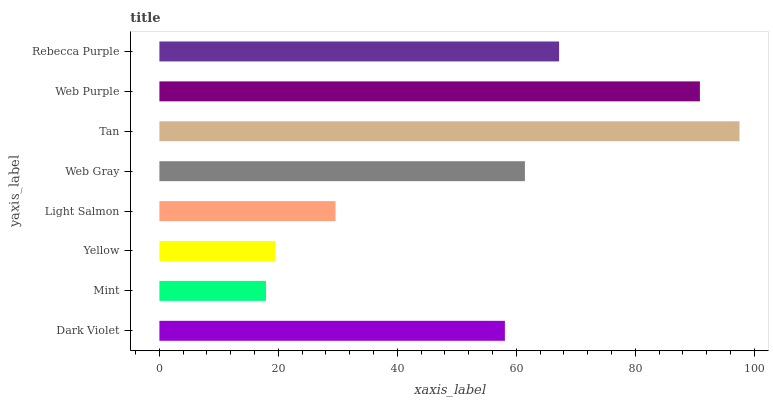Is Mint the minimum?
Answer yes or no. Yes. Is Tan the maximum?
Answer yes or no. Yes. Is Yellow the minimum?
Answer yes or no. No. Is Yellow the maximum?
Answer yes or no. No. Is Yellow greater than Mint?
Answer yes or no. Yes. Is Mint less than Yellow?
Answer yes or no. Yes. Is Mint greater than Yellow?
Answer yes or no. No. Is Yellow less than Mint?
Answer yes or no. No. Is Web Gray the high median?
Answer yes or no. Yes. Is Dark Violet the low median?
Answer yes or no. Yes. Is Light Salmon the high median?
Answer yes or no. No. Is Tan the low median?
Answer yes or no. No. 